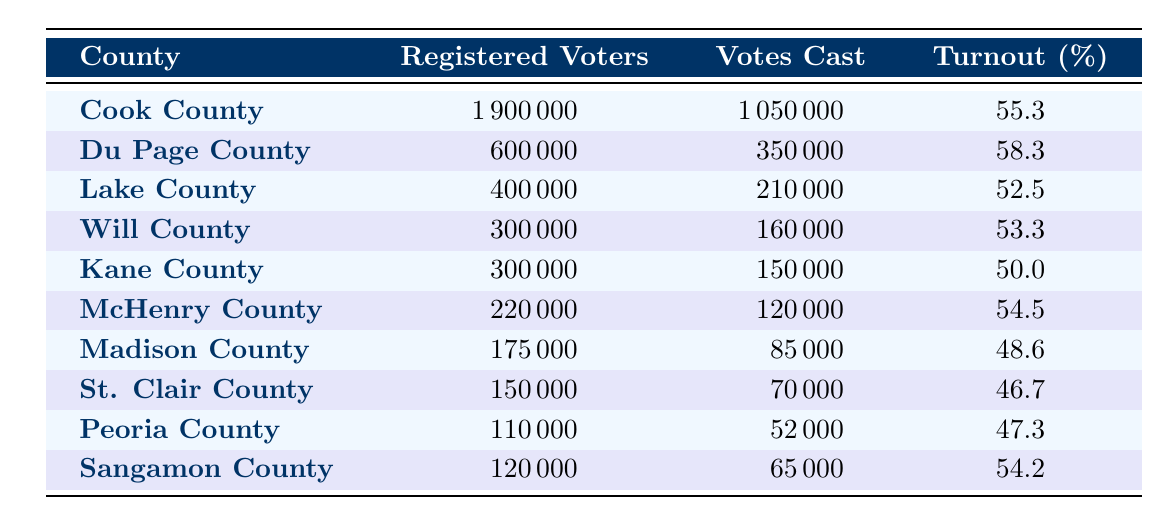What is the voter turnout percentage for Cook County? The table specifies that the voter turnout percentage for Cook County is 55.3 percent.
Answer: 55.3% Which county had the highest number of votes cast? Looking at the table, Cook County had the highest number of votes cast with 1,050,000 votes.
Answer: Cook County What is the total number of registered voters in Du Page County? The total registered voters in Du Page County, as stated in the table, is 600,000.
Answer: 600,000 Is the voter turnout in St. Clair County higher than that in Madison County? The table shows St. Clair County has a turnout of 46.7 percent and Madison County has a turnout of 48.6 percent. Therefore, St. Clair County's turnout is lower than Madison County's.
Answer: No What is the average voter turnout percentage for all the counties listed? To find the average, sum all the turnout percentages and divide by the number of counties: (55.3 + 58.3 + 52.5 + 53.3 + 50.0 + 54.5 + 48.6 + 46.7 + 47.3 + 54.2) =  467.8, then 467.8 / 10 = 46.78.
Answer: 46.78% Which county has a voter turnout percentage closest to 50%? Comparing the percentages, Kane County has a turnout of exactly 50.0 percent, which is the closest to 50%.
Answer: Kane County How many total votes were cast across all counties? Adding the votes cast in each county: (1,050,000 + 350,000 + 210,000 + 160,000 + 150,000 + 120,000 + 85,000 + 70,000 + 52,000 + 65,000) gives a total of 2,132,000 votes cast.
Answer: 2,132,000 Is it true that more than half of the registered voters in Lake County participated in the election? The table indicates that Lake County had a voter turnout of 52.5 percent, which is less than half of the registered voters.
Answer: No What is the difference in voter turnout percentage between Cook County and Du Page County? The turnout for Cook County is 55.3 percent, and for Du Page County, it’s 58.3 percent. The difference is 58.3 - 55.3 = 3.0 percentage points.
Answer: 3.0% Which counties had a voter turnout below 50%? Referring to the table, Madison County (48.6%), St. Clair County (46.7%), and Kane County (50.0%) had a turnout below 50%.
Answer: Madison, St. Clair, Kane 